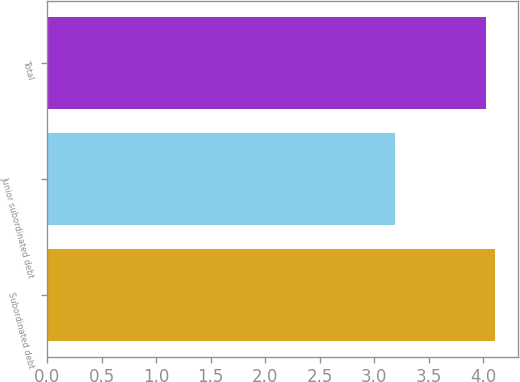Convert chart to OTSL. <chart><loc_0><loc_0><loc_500><loc_500><bar_chart><fcel>Subordinated debt<fcel>Junior subordinated debt<fcel>Total<nl><fcel>4.11<fcel>3.19<fcel>4.02<nl></chart> 